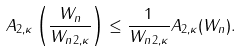<formula> <loc_0><loc_0><loc_500><loc_500>A _ { 2 , \kappa } \left ( \frac { W _ { n } } { \| W _ { n } \| _ { 2 , \kappa } } \right ) \leq \frac { 1 } { \| W _ { n } \| _ { 2 , \kappa } } A _ { 2 , \kappa } ( W _ { n } ) .</formula> 